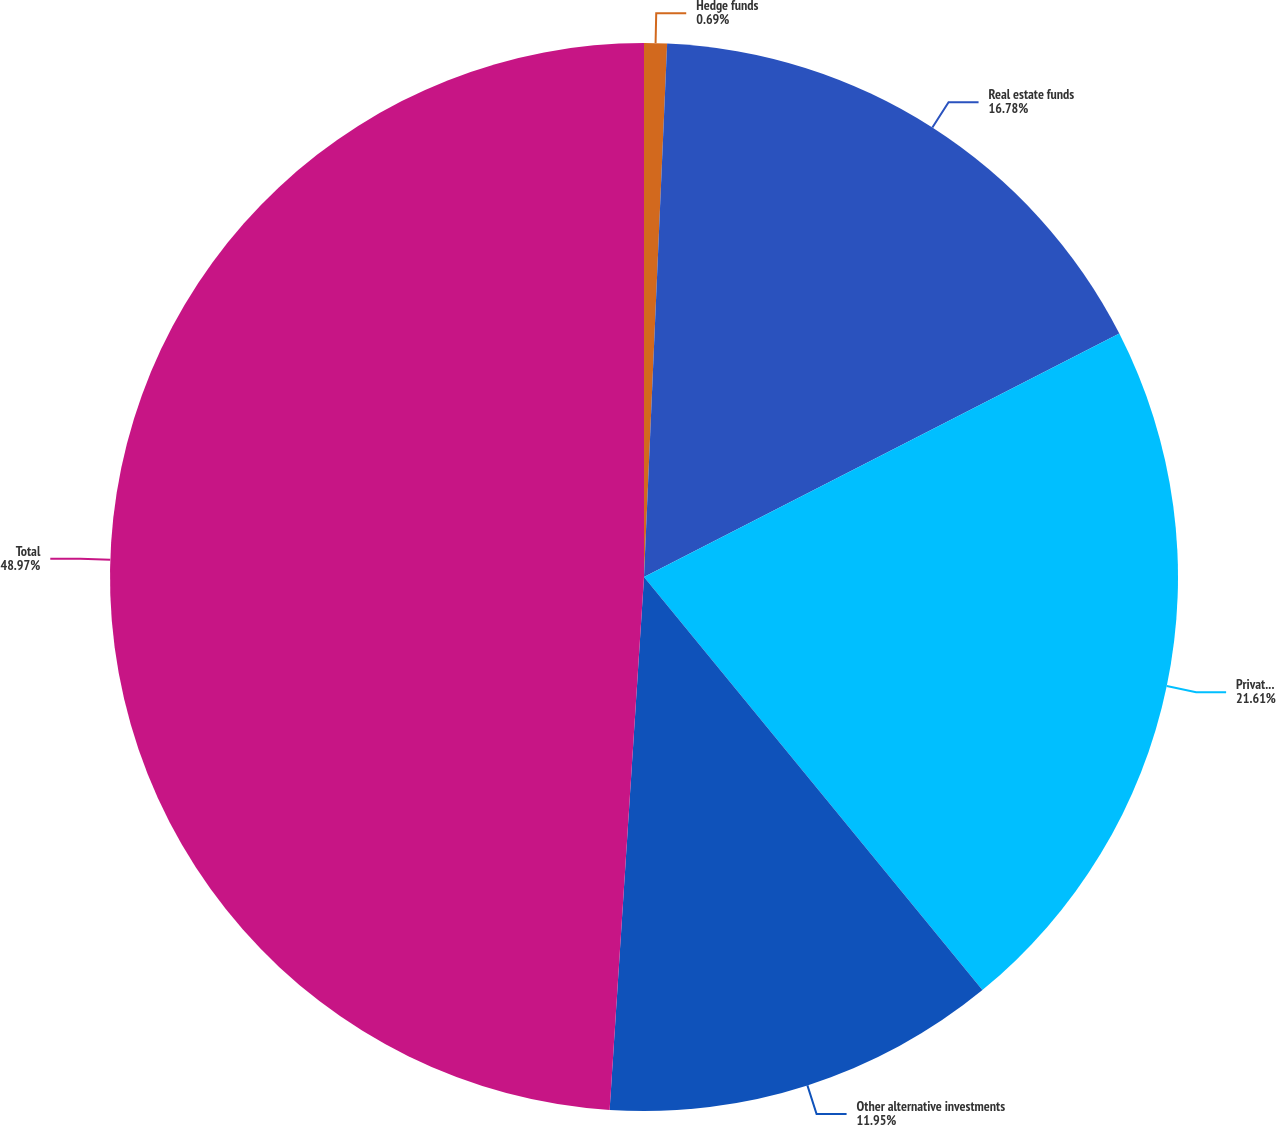Convert chart to OTSL. <chart><loc_0><loc_0><loc_500><loc_500><pie_chart><fcel>Hedge funds<fcel>Real estate funds<fcel>Private equity and other funds<fcel>Other alternative investments<fcel>Total<nl><fcel>0.69%<fcel>16.78%<fcel>21.61%<fcel>11.95%<fcel>48.98%<nl></chart> 